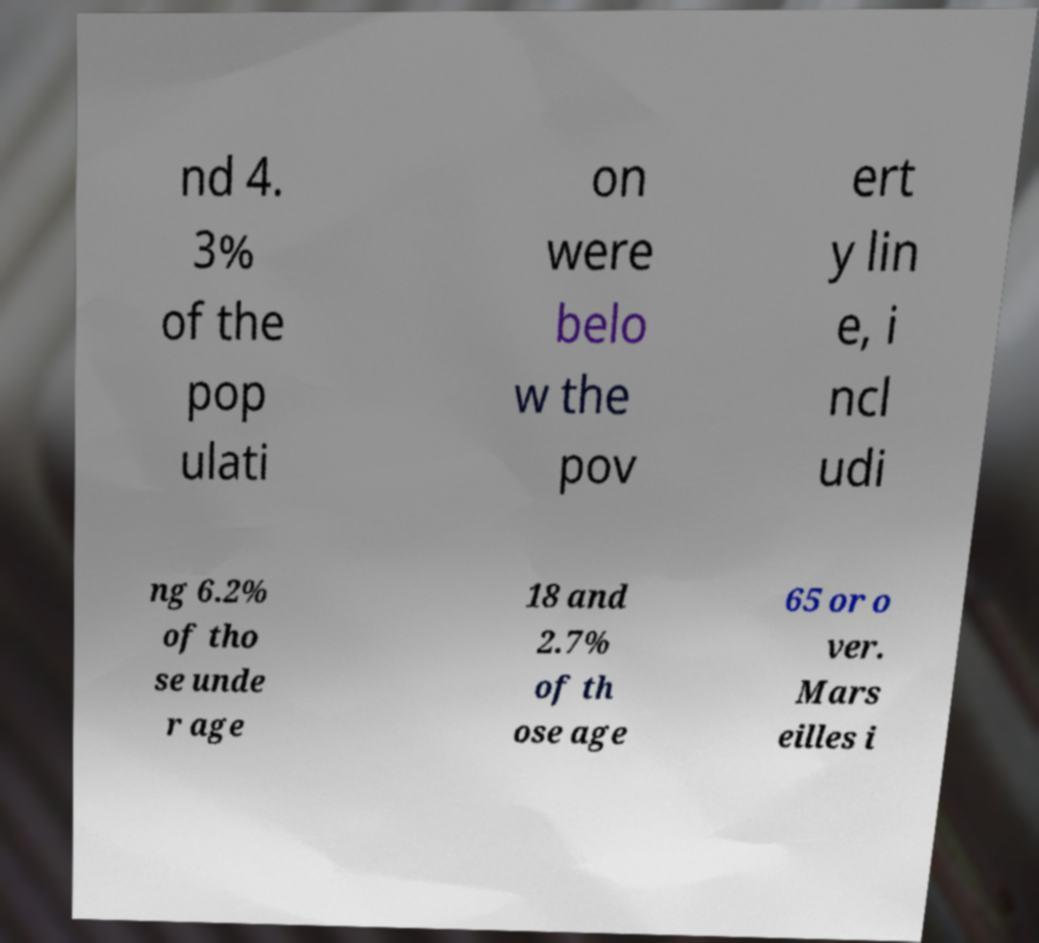I need the written content from this picture converted into text. Can you do that? nd 4. 3% of the pop ulati on were belo w the pov ert y lin e, i ncl udi ng 6.2% of tho se unde r age 18 and 2.7% of th ose age 65 or o ver. Mars eilles i 